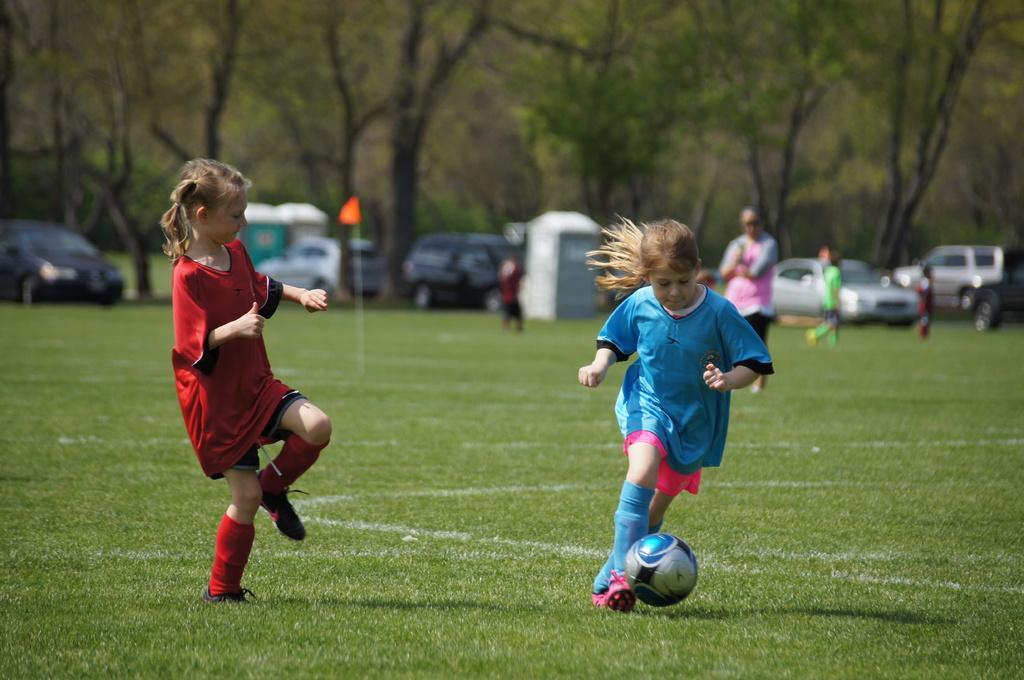In one or two sentences, can you explain what this image depicts? On the background of the picture we can see trees and fe vehicles parked over there. This is a flag in orange colour. This is a playground. here we can see few persons playing. This is a ball. 